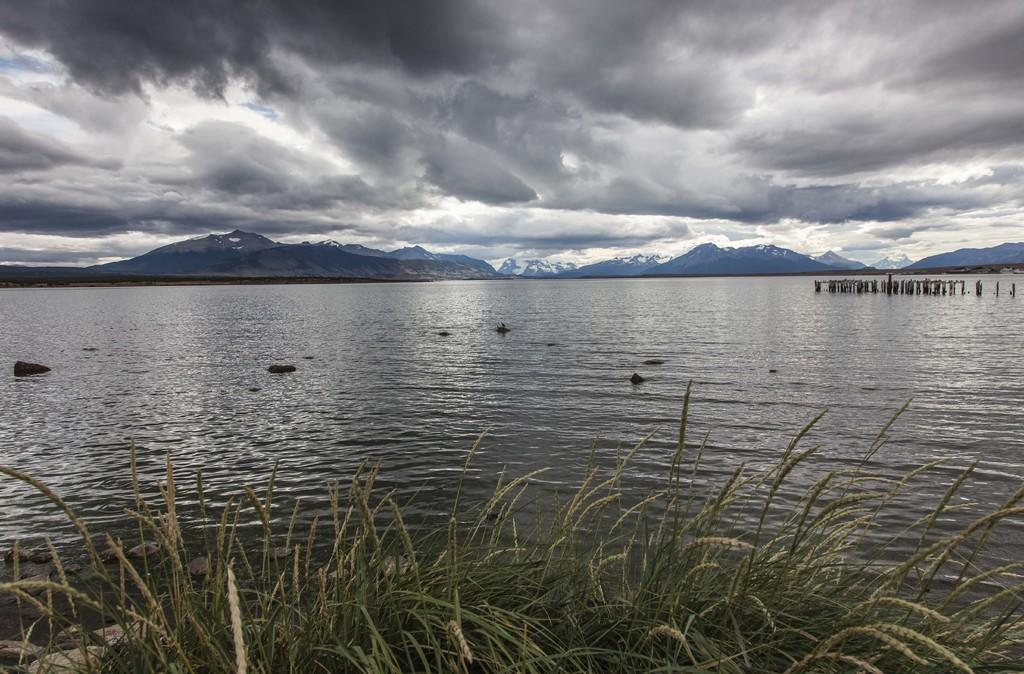What type of natural formation can be seen in the image? A: There are mountains in the image. What is visible in the sky at the top of the image? There are clouds in the sky at the top of the image. What type of vegetation is present at the bottom of the image? There are plants at the bottom of the image. What is the water in the image used for? The water in the image is not explicitly used for anything, but it is visible. What structures can be seen in the image? There are poles in the image. Can you tell me how many fans are visible in the image? There are no fans present in the image. What type of duck can be seen swimming in the water in the image? There are no ducks present in the image, and the water is not depicted as being deep enough for swimming. 